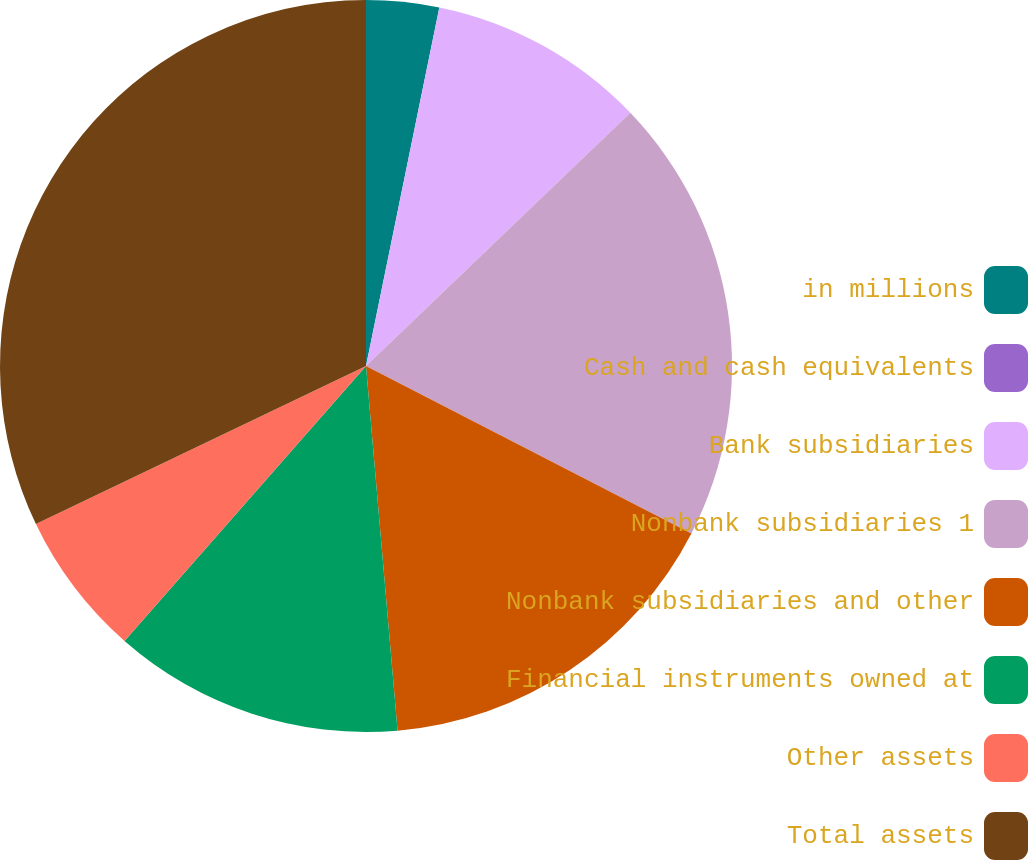Convert chart. <chart><loc_0><loc_0><loc_500><loc_500><pie_chart><fcel>in millions<fcel>Cash and cash equivalents<fcel>Bank subsidiaries<fcel>Nonbank subsidiaries 1<fcel>Nonbank subsidiaries and other<fcel>Financial instruments owned at<fcel>Other assets<fcel>Total assets<nl><fcel>3.21%<fcel>0.0%<fcel>9.63%<fcel>19.72%<fcel>16.05%<fcel>12.84%<fcel>6.42%<fcel>32.1%<nl></chart> 